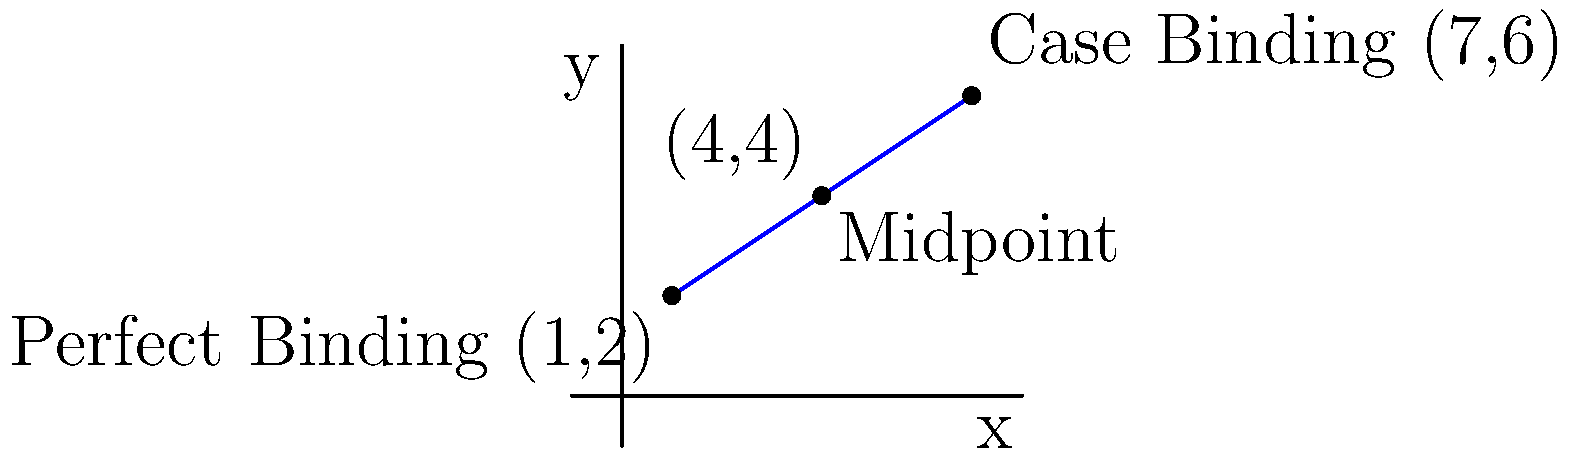As a self-published author exploring book binding options, you're comparing Perfect Binding and Case Binding. On a coordinate plane, Perfect Binding is represented by point $(1,2)$ and Case Binding by point $(7,6)$. What are the coordinates of the midpoint between these two binding styles, which could represent a balanced choice? To find the midpoint of a line segment, we can use the midpoint formula:

$$ \text{Midpoint} = \left(\frac{x_1 + x_2}{2}, \frac{y_1 + y_2}{2}\right) $$

Where $(x_1, y_1)$ is the first point and $(x_2, y_2)$ is the second point.

1. Identify the coordinates:
   Perfect Binding: $(x_1, y_1) = (1, 2)$
   Case Binding: $(x_2, y_2) = (7, 6)$

2. Calculate the x-coordinate of the midpoint:
   $$ x = \frac{x_1 + x_2}{2} = \frac{1 + 7}{2} = \frac{8}{2} = 4 $$

3. Calculate the y-coordinate of the midpoint:
   $$ y = \frac{y_1 + y_2}{2} = \frac{2 + 6}{2} = \frac{8}{2} = 4 $$

4. Combine the results:
   The midpoint coordinates are $(4, 4)$.
Answer: $(4, 4)$ 